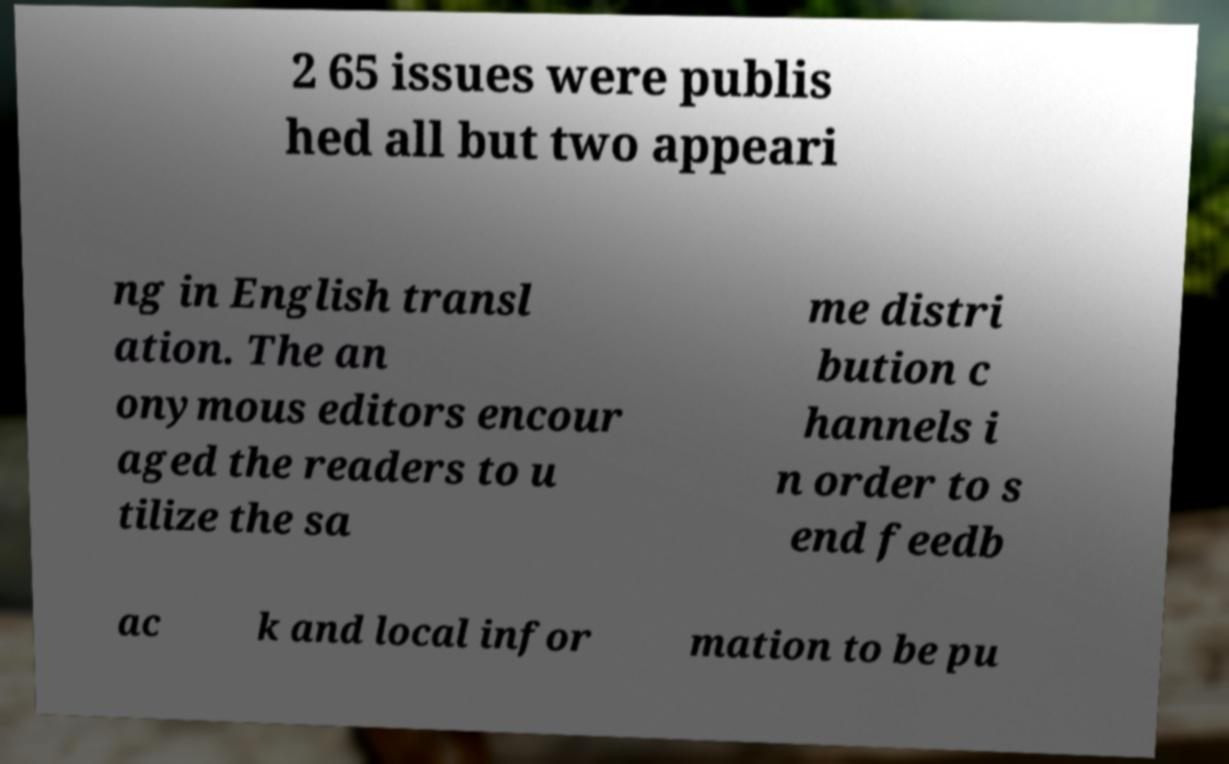I need the written content from this picture converted into text. Can you do that? 2 65 issues were publis hed all but two appeari ng in English transl ation. The an onymous editors encour aged the readers to u tilize the sa me distri bution c hannels i n order to s end feedb ac k and local infor mation to be pu 